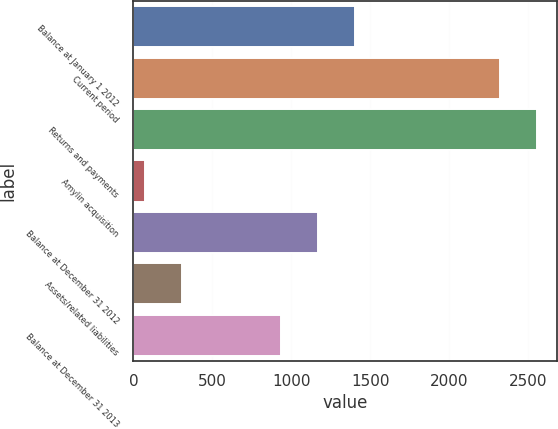Convert chart. <chart><loc_0><loc_0><loc_500><loc_500><bar_chart><fcel>Balance at January 1 2012<fcel>Current period<fcel>Returns and payments<fcel>Amylin acquisition<fcel>Balance at December 31 2012<fcel>Assets/related liabilities<fcel>Balance at December 31 2013<nl><fcel>1405.6<fcel>2323<fcel>2556.8<fcel>76<fcel>1171.8<fcel>309.8<fcel>938<nl></chart> 